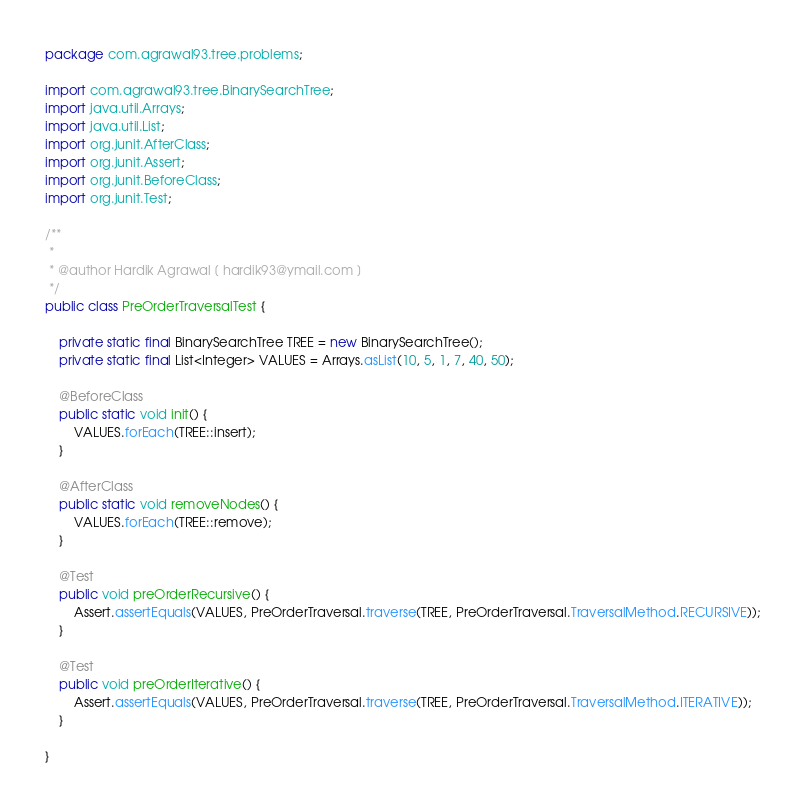<code> <loc_0><loc_0><loc_500><loc_500><_Java_>package com.agrawal93.tree.problems;

import com.agrawal93.tree.BinarySearchTree;
import java.util.Arrays;
import java.util.List;
import org.junit.AfterClass;
import org.junit.Assert;
import org.junit.BeforeClass;
import org.junit.Test;

/**
 *
 * @author Hardik Agrawal [ hardik93@ymail.com ]
 */
public class PreOrderTraversalTest {

    private static final BinarySearchTree TREE = new BinarySearchTree();
    private static final List<Integer> VALUES = Arrays.asList(10, 5, 1, 7, 40, 50);

    @BeforeClass
    public static void init() {
        VALUES.forEach(TREE::insert);
    }

    @AfterClass
    public static void removeNodes() {
        VALUES.forEach(TREE::remove);
    }

    @Test
    public void preOrderRecursive() {
        Assert.assertEquals(VALUES, PreOrderTraversal.traverse(TREE, PreOrderTraversal.TraversalMethod.RECURSIVE));
    }

    @Test
    public void preOrderIterative() {
        Assert.assertEquals(VALUES, PreOrderTraversal.traverse(TREE, PreOrderTraversal.TraversalMethod.ITERATIVE));
    }

}
</code> 